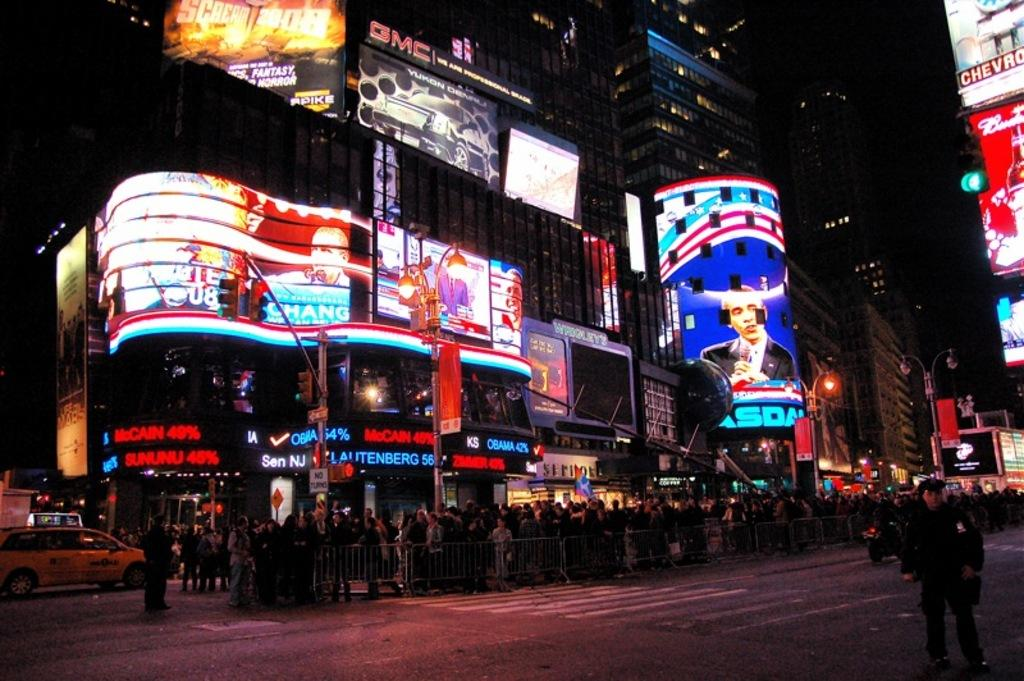<image>
Present a compact description of the photo's key features. A busy city street at night with a chevrolet sign among others. 